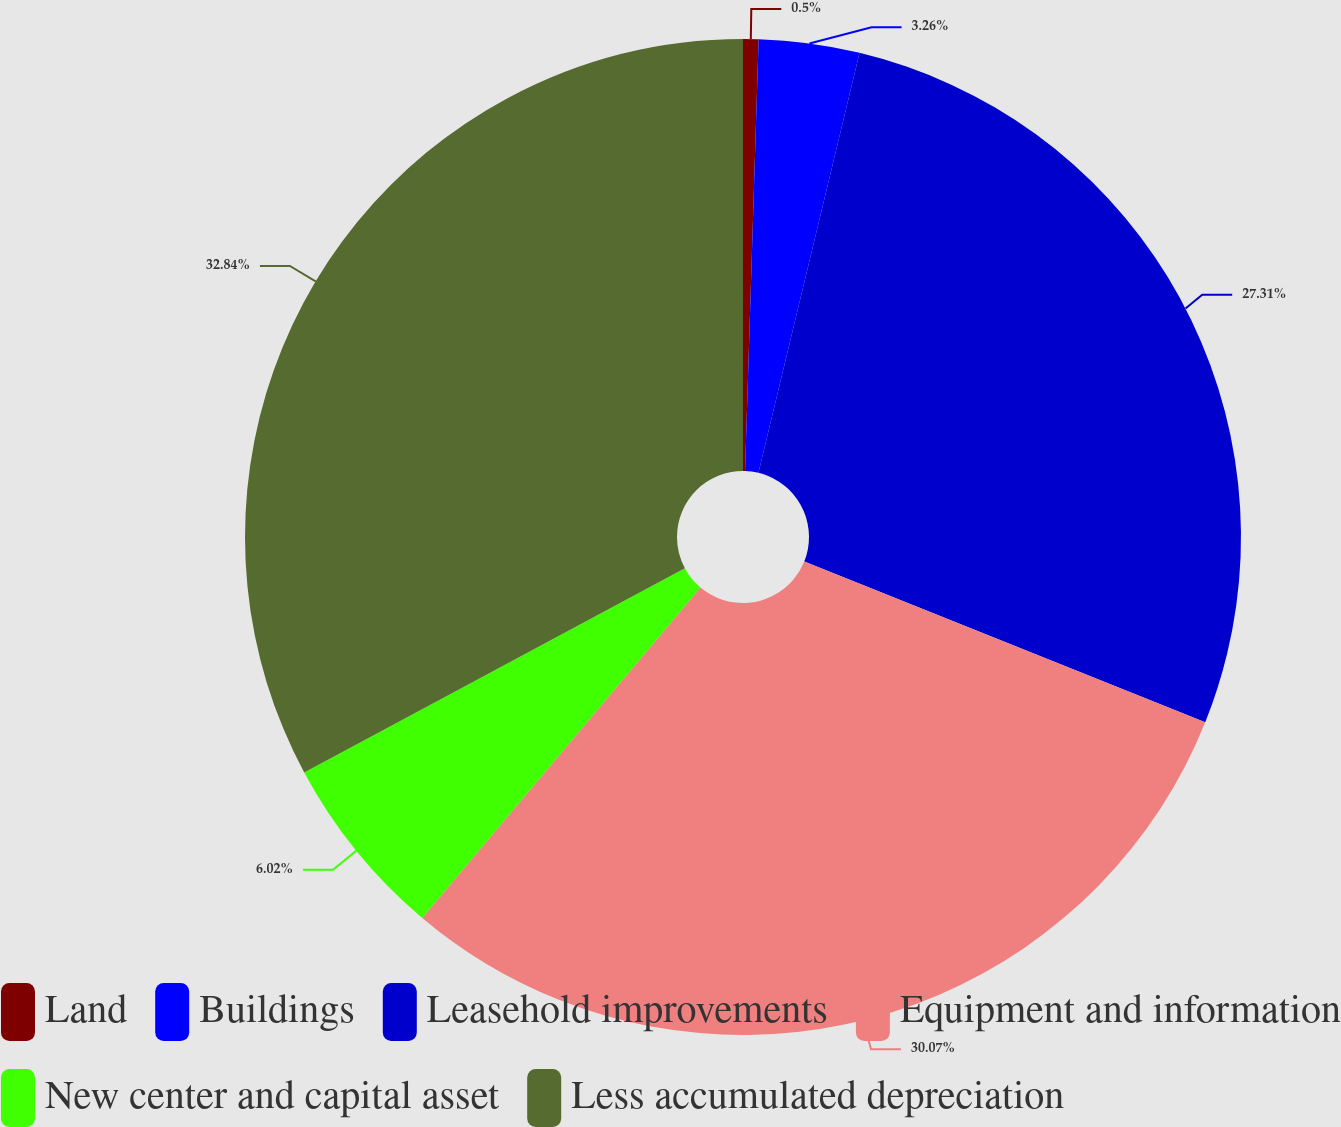Convert chart to OTSL. <chart><loc_0><loc_0><loc_500><loc_500><pie_chart><fcel>Land<fcel>Buildings<fcel>Leasehold improvements<fcel>Equipment and information<fcel>New center and capital asset<fcel>Less accumulated depreciation<nl><fcel>0.5%<fcel>3.26%<fcel>27.31%<fcel>30.07%<fcel>6.02%<fcel>32.84%<nl></chart> 